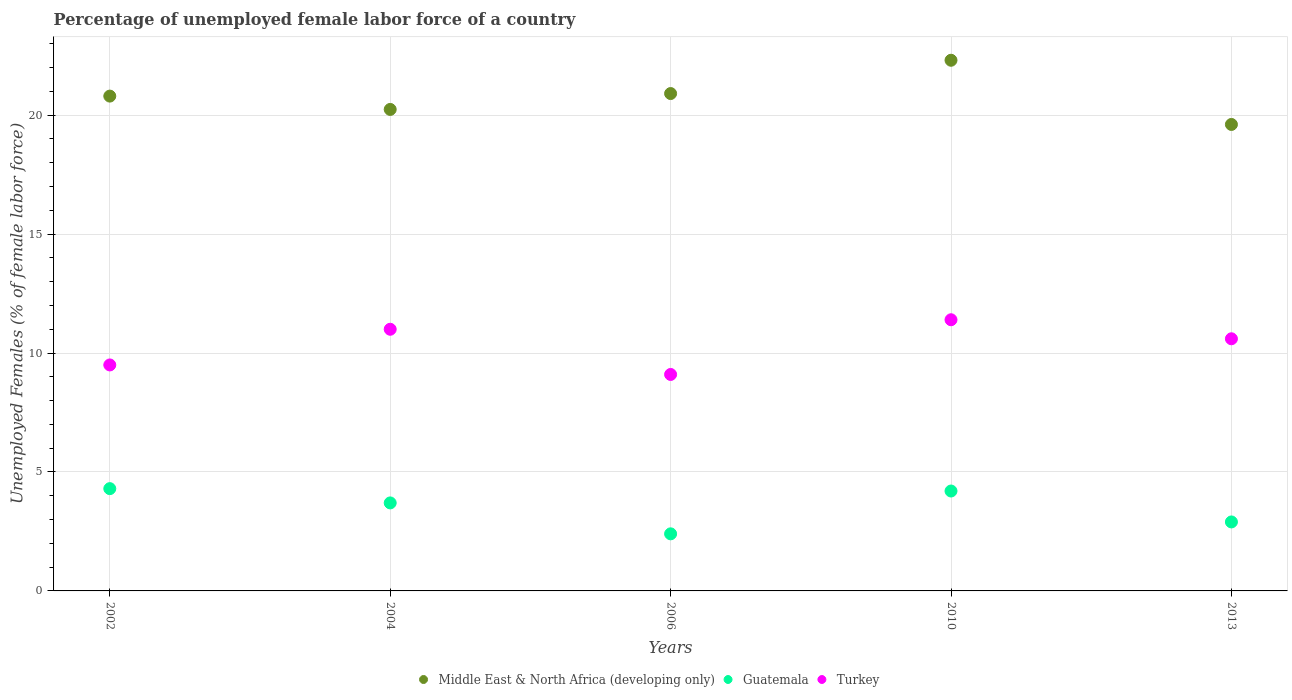How many different coloured dotlines are there?
Your answer should be very brief. 3. Is the number of dotlines equal to the number of legend labels?
Your answer should be compact. Yes. Across all years, what is the maximum percentage of unemployed female labor force in Middle East & North Africa (developing only)?
Give a very brief answer. 22.31. Across all years, what is the minimum percentage of unemployed female labor force in Guatemala?
Offer a very short reply. 2.4. In which year was the percentage of unemployed female labor force in Turkey minimum?
Your answer should be very brief. 2006. What is the total percentage of unemployed female labor force in Middle East & North Africa (developing only) in the graph?
Your answer should be very brief. 103.87. What is the difference between the percentage of unemployed female labor force in Middle East & North Africa (developing only) in 2010 and that in 2013?
Provide a succinct answer. 2.7. What is the difference between the percentage of unemployed female labor force in Middle East & North Africa (developing only) in 2006 and the percentage of unemployed female labor force in Guatemala in 2010?
Your answer should be compact. 16.71. What is the average percentage of unemployed female labor force in Middle East & North Africa (developing only) per year?
Offer a terse response. 20.77. In the year 2006, what is the difference between the percentage of unemployed female labor force in Middle East & North Africa (developing only) and percentage of unemployed female labor force in Turkey?
Your response must be concise. 11.81. What is the ratio of the percentage of unemployed female labor force in Guatemala in 2004 to that in 2010?
Give a very brief answer. 0.88. Is the percentage of unemployed female labor force in Turkey in 2006 less than that in 2010?
Provide a succinct answer. Yes. Is the difference between the percentage of unemployed female labor force in Middle East & North Africa (developing only) in 2002 and 2004 greater than the difference between the percentage of unemployed female labor force in Turkey in 2002 and 2004?
Your answer should be very brief. Yes. What is the difference between the highest and the second highest percentage of unemployed female labor force in Guatemala?
Keep it short and to the point. 0.1. What is the difference between the highest and the lowest percentage of unemployed female labor force in Turkey?
Make the answer very short. 2.3. In how many years, is the percentage of unemployed female labor force in Turkey greater than the average percentage of unemployed female labor force in Turkey taken over all years?
Keep it short and to the point. 3. Is it the case that in every year, the sum of the percentage of unemployed female labor force in Guatemala and percentage of unemployed female labor force in Turkey  is greater than the percentage of unemployed female labor force in Middle East & North Africa (developing only)?
Your answer should be very brief. No. Does the percentage of unemployed female labor force in Turkey monotonically increase over the years?
Your answer should be compact. No. Is the percentage of unemployed female labor force in Guatemala strictly less than the percentage of unemployed female labor force in Middle East & North Africa (developing only) over the years?
Provide a succinct answer. Yes. How many dotlines are there?
Provide a short and direct response. 3. What is the difference between two consecutive major ticks on the Y-axis?
Your response must be concise. 5. Where does the legend appear in the graph?
Make the answer very short. Bottom center. How many legend labels are there?
Give a very brief answer. 3. How are the legend labels stacked?
Ensure brevity in your answer.  Horizontal. What is the title of the graph?
Offer a terse response. Percentage of unemployed female labor force of a country. What is the label or title of the X-axis?
Provide a succinct answer. Years. What is the label or title of the Y-axis?
Ensure brevity in your answer.  Unemployed Females (% of female labor force). What is the Unemployed Females (% of female labor force) in Middle East & North Africa (developing only) in 2002?
Keep it short and to the point. 20.8. What is the Unemployed Females (% of female labor force) of Guatemala in 2002?
Your answer should be very brief. 4.3. What is the Unemployed Females (% of female labor force) of Middle East & North Africa (developing only) in 2004?
Ensure brevity in your answer.  20.24. What is the Unemployed Females (% of female labor force) of Guatemala in 2004?
Provide a succinct answer. 3.7. What is the Unemployed Females (% of female labor force) in Middle East & North Africa (developing only) in 2006?
Provide a succinct answer. 20.91. What is the Unemployed Females (% of female labor force) of Guatemala in 2006?
Your answer should be compact. 2.4. What is the Unemployed Females (% of female labor force) of Turkey in 2006?
Provide a short and direct response. 9.1. What is the Unemployed Females (% of female labor force) of Middle East & North Africa (developing only) in 2010?
Your answer should be compact. 22.31. What is the Unemployed Females (% of female labor force) of Guatemala in 2010?
Make the answer very short. 4.2. What is the Unemployed Females (% of female labor force) of Turkey in 2010?
Your answer should be compact. 11.4. What is the Unemployed Females (% of female labor force) in Middle East & North Africa (developing only) in 2013?
Keep it short and to the point. 19.61. What is the Unemployed Females (% of female labor force) in Guatemala in 2013?
Your answer should be compact. 2.9. What is the Unemployed Females (% of female labor force) of Turkey in 2013?
Keep it short and to the point. 10.6. Across all years, what is the maximum Unemployed Females (% of female labor force) of Middle East & North Africa (developing only)?
Provide a succinct answer. 22.31. Across all years, what is the maximum Unemployed Females (% of female labor force) of Guatemala?
Ensure brevity in your answer.  4.3. Across all years, what is the maximum Unemployed Females (% of female labor force) of Turkey?
Your answer should be very brief. 11.4. Across all years, what is the minimum Unemployed Females (% of female labor force) in Middle East & North Africa (developing only)?
Ensure brevity in your answer.  19.61. Across all years, what is the minimum Unemployed Females (% of female labor force) in Guatemala?
Provide a succinct answer. 2.4. Across all years, what is the minimum Unemployed Females (% of female labor force) in Turkey?
Your response must be concise. 9.1. What is the total Unemployed Females (% of female labor force) of Middle East & North Africa (developing only) in the graph?
Provide a succinct answer. 103.87. What is the total Unemployed Females (% of female labor force) of Guatemala in the graph?
Provide a succinct answer. 17.5. What is the total Unemployed Females (% of female labor force) of Turkey in the graph?
Offer a very short reply. 51.6. What is the difference between the Unemployed Females (% of female labor force) of Middle East & North Africa (developing only) in 2002 and that in 2004?
Ensure brevity in your answer.  0.56. What is the difference between the Unemployed Females (% of female labor force) in Guatemala in 2002 and that in 2004?
Provide a short and direct response. 0.6. What is the difference between the Unemployed Females (% of female labor force) in Turkey in 2002 and that in 2004?
Your answer should be compact. -1.5. What is the difference between the Unemployed Females (% of female labor force) of Middle East & North Africa (developing only) in 2002 and that in 2006?
Your response must be concise. -0.11. What is the difference between the Unemployed Females (% of female labor force) of Turkey in 2002 and that in 2006?
Your answer should be compact. 0.4. What is the difference between the Unemployed Females (% of female labor force) of Middle East & North Africa (developing only) in 2002 and that in 2010?
Your answer should be very brief. -1.51. What is the difference between the Unemployed Females (% of female labor force) of Turkey in 2002 and that in 2010?
Your answer should be compact. -1.9. What is the difference between the Unemployed Females (% of female labor force) of Middle East & North Africa (developing only) in 2002 and that in 2013?
Your answer should be very brief. 1.19. What is the difference between the Unemployed Females (% of female labor force) of Guatemala in 2002 and that in 2013?
Provide a short and direct response. 1.4. What is the difference between the Unemployed Females (% of female labor force) of Middle East & North Africa (developing only) in 2004 and that in 2006?
Your response must be concise. -0.67. What is the difference between the Unemployed Females (% of female labor force) of Turkey in 2004 and that in 2006?
Make the answer very short. 1.9. What is the difference between the Unemployed Females (% of female labor force) in Middle East & North Africa (developing only) in 2004 and that in 2010?
Your answer should be compact. -2.07. What is the difference between the Unemployed Females (% of female labor force) of Turkey in 2004 and that in 2010?
Your answer should be very brief. -0.4. What is the difference between the Unemployed Females (% of female labor force) of Middle East & North Africa (developing only) in 2004 and that in 2013?
Make the answer very short. 0.63. What is the difference between the Unemployed Females (% of female labor force) of Middle East & North Africa (developing only) in 2006 and that in 2010?
Give a very brief answer. -1.4. What is the difference between the Unemployed Females (% of female labor force) of Guatemala in 2006 and that in 2010?
Give a very brief answer. -1.8. What is the difference between the Unemployed Females (% of female labor force) of Turkey in 2006 and that in 2010?
Make the answer very short. -2.3. What is the difference between the Unemployed Females (% of female labor force) of Middle East & North Africa (developing only) in 2006 and that in 2013?
Offer a terse response. 1.3. What is the difference between the Unemployed Females (% of female labor force) in Guatemala in 2006 and that in 2013?
Make the answer very short. -0.5. What is the difference between the Unemployed Females (% of female labor force) of Middle East & North Africa (developing only) in 2010 and that in 2013?
Offer a terse response. 2.7. What is the difference between the Unemployed Females (% of female labor force) of Middle East & North Africa (developing only) in 2002 and the Unemployed Females (% of female labor force) of Guatemala in 2004?
Give a very brief answer. 17.1. What is the difference between the Unemployed Females (% of female labor force) of Middle East & North Africa (developing only) in 2002 and the Unemployed Females (% of female labor force) of Turkey in 2004?
Offer a terse response. 9.8. What is the difference between the Unemployed Females (% of female labor force) of Guatemala in 2002 and the Unemployed Females (% of female labor force) of Turkey in 2004?
Offer a terse response. -6.7. What is the difference between the Unemployed Females (% of female labor force) of Middle East & North Africa (developing only) in 2002 and the Unemployed Females (% of female labor force) of Guatemala in 2006?
Provide a short and direct response. 18.4. What is the difference between the Unemployed Females (% of female labor force) in Middle East & North Africa (developing only) in 2002 and the Unemployed Females (% of female labor force) in Turkey in 2006?
Offer a very short reply. 11.7. What is the difference between the Unemployed Females (% of female labor force) in Middle East & North Africa (developing only) in 2002 and the Unemployed Females (% of female labor force) in Guatemala in 2010?
Ensure brevity in your answer.  16.6. What is the difference between the Unemployed Females (% of female labor force) in Middle East & North Africa (developing only) in 2002 and the Unemployed Females (% of female labor force) in Turkey in 2010?
Give a very brief answer. 9.4. What is the difference between the Unemployed Females (% of female labor force) of Middle East & North Africa (developing only) in 2002 and the Unemployed Females (% of female labor force) of Guatemala in 2013?
Give a very brief answer. 17.9. What is the difference between the Unemployed Females (% of female labor force) in Middle East & North Africa (developing only) in 2002 and the Unemployed Females (% of female labor force) in Turkey in 2013?
Provide a short and direct response. 10.2. What is the difference between the Unemployed Females (% of female labor force) of Middle East & North Africa (developing only) in 2004 and the Unemployed Females (% of female labor force) of Guatemala in 2006?
Make the answer very short. 17.84. What is the difference between the Unemployed Females (% of female labor force) in Middle East & North Africa (developing only) in 2004 and the Unemployed Females (% of female labor force) in Turkey in 2006?
Provide a short and direct response. 11.14. What is the difference between the Unemployed Females (% of female labor force) in Guatemala in 2004 and the Unemployed Females (% of female labor force) in Turkey in 2006?
Make the answer very short. -5.4. What is the difference between the Unemployed Females (% of female labor force) of Middle East & North Africa (developing only) in 2004 and the Unemployed Females (% of female labor force) of Guatemala in 2010?
Make the answer very short. 16.04. What is the difference between the Unemployed Females (% of female labor force) in Middle East & North Africa (developing only) in 2004 and the Unemployed Females (% of female labor force) in Turkey in 2010?
Your answer should be compact. 8.84. What is the difference between the Unemployed Females (% of female labor force) of Middle East & North Africa (developing only) in 2004 and the Unemployed Females (% of female labor force) of Guatemala in 2013?
Make the answer very short. 17.34. What is the difference between the Unemployed Females (% of female labor force) of Middle East & North Africa (developing only) in 2004 and the Unemployed Females (% of female labor force) of Turkey in 2013?
Make the answer very short. 9.64. What is the difference between the Unemployed Females (% of female labor force) in Guatemala in 2004 and the Unemployed Females (% of female labor force) in Turkey in 2013?
Offer a terse response. -6.9. What is the difference between the Unemployed Females (% of female labor force) in Middle East & North Africa (developing only) in 2006 and the Unemployed Females (% of female labor force) in Guatemala in 2010?
Ensure brevity in your answer.  16.71. What is the difference between the Unemployed Females (% of female labor force) of Middle East & North Africa (developing only) in 2006 and the Unemployed Females (% of female labor force) of Turkey in 2010?
Your answer should be compact. 9.51. What is the difference between the Unemployed Females (% of female labor force) in Guatemala in 2006 and the Unemployed Females (% of female labor force) in Turkey in 2010?
Your response must be concise. -9. What is the difference between the Unemployed Females (% of female labor force) of Middle East & North Africa (developing only) in 2006 and the Unemployed Females (% of female labor force) of Guatemala in 2013?
Your answer should be compact. 18.01. What is the difference between the Unemployed Females (% of female labor force) of Middle East & North Africa (developing only) in 2006 and the Unemployed Females (% of female labor force) of Turkey in 2013?
Provide a succinct answer. 10.31. What is the difference between the Unemployed Females (% of female labor force) of Guatemala in 2006 and the Unemployed Females (% of female labor force) of Turkey in 2013?
Ensure brevity in your answer.  -8.2. What is the difference between the Unemployed Females (% of female labor force) of Middle East & North Africa (developing only) in 2010 and the Unemployed Females (% of female labor force) of Guatemala in 2013?
Offer a terse response. 19.41. What is the difference between the Unemployed Females (% of female labor force) of Middle East & North Africa (developing only) in 2010 and the Unemployed Females (% of female labor force) of Turkey in 2013?
Keep it short and to the point. 11.71. What is the difference between the Unemployed Females (% of female labor force) in Guatemala in 2010 and the Unemployed Females (% of female labor force) in Turkey in 2013?
Provide a succinct answer. -6.4. What is the average Unemployed Females (% of female labor force) in Middle East & North Africa (developing only) per year?
Provide a succinct answer. 20.77. What is the average Unemployed Females (% of female labor force) of Guatemala per year?
Provide a succinct answer. 3.5. What is the average Unemployed Females (% of female labor force) of Turkey per year?
Provide a short and direct response. 10.32. In the year 2002, what is the difference between the Unemployed Females (% of female labor force) in Middle East & North Africa (developing only) and Unemployed Females (% of female labor force) in Guatemala?
Offer a terse response. 16.5. In the year 2002, what is the difference between the Unemployed Females (% of female labor force) in Middle East & North Africa (developing only) and Unemployed Females (% of female labor force) in Turkey?
Make the answer very short. 11.3. In the year 2004, what is the difference between the Unemployed Females (% of female labor force) of Middle East & North Africa (developing only) and Unemployed Females (% of female labor force) of Guatemala?
Offer a very short reply. 16.54. In the year 2004, what is the difference between the Unemployed Females (% of female labor force) of Middle East & North Africa (developing only) and Unemployed Females (% of female labor force) of Turkey?
Offer a terse response. 9.24. In the year 2006, what is the difference between the Unemployed Females (% of female labor force) in Middle East & North Africa (developing only) and Unemployed Females (% of female labor force) in Guatemala?
Your answer should be very brief. 18.51. In the year 2006, what is the difference between the Unemployed Females (% of female labor force) in Middle East & North Africa (developing only) and Unemployed Females (% of female labor force) in Turkey?
Give a very brief answer. 11.81. In the year 2010, what is the difference between the Unemployed Females (% of female labor force) in Middle East & North Africa (developing only) and Unemployed Females (% of female labor force) in Guatemala?
Make the answer very short. 18.11. In the year 2010, what is the difference between the Unemployed Females (% of female labor force) in Middle East & North Africa (developing only) and Unemployed Females (% of female labor force) in Turkey?
Keep it short and to the point. 10.91. In the year 2010, what is the difference between the Unemployed Females (% of female labor force) of Guatemala and Unemployed Females (% of female labor force) of Turkey?
Make the answer very short. -7.2. In the year 2013, what is the difference between the Unemployed Females (% of female labor force) of Middle East & North Africa (developing only) and Unemployed Females (% of female labor force) of Guatemala?
Your answer should be very brief. 16.71. In the year 2013, what is the difference between the Unemployed Females (% of female labor force) in Middle East & North Africa (developing only) and Unemployed Females (% of female labor force) in Turkey?
Keep it short and to the point. 9.01. In the year 2013, what is the difference between the Unemployed Females (% of female labor force) in Guatemala and Unemployed Females (% of female labor force) in Turkey?
Provide a short and direct response. -7.7. What is the ratio of the Unemployed Females (% of female labor force) of Middle East & North Africa (developing only) in 2002 to that in 2004?
Your answer should be compact. 1.03. What is the ratio of the Unemployed Females (% of female labor force) of Guatemala in 2002 to that in 2004?
Make the answer very short. 1.16. What is the ratio of the Unemployed Females (% of female labor force) of Turkey in 2002 to that in 2004?
Provide a succinct answer. 0.86. What is the ratio of the Unemployed Females (% of female labor force) of Guatemala in 2002 to that in 2006?
Offer a very short reply. 1.79. What is the ratio of the Unemployed Females (% of female labor force) in Turkey in 2002 to that in 2006?
Make the answer very short. 1.04. What is the ratio of the Unemployed Females (% of female labor force) in Middle East & North Africa (developing only) in 2002 to that in 2010?
Keep it short and to the point. 0.93. What is the ratio of the Unemployed Females (% of female labor force) in Guatemala in 2002 to that in 2010?
Your answer should be compact. 1.02. What is the ratio of the Unemployed Females (% of female labor force) of Turkey in 2002 to that in 2010?
Your answer should be very brief. 0.83. What is the ratio of the Unemployed Females (% of female labor force) of Middle East & North Africa (developing only) in 2002 to that in 2013?
Ensure brevity in your answer.  1.06. What is the ratio of the Unemployed Females (% of female labor force) of Guatemala in 2002 to that in 2013?
Ensure brevity in your answer.  1.48. What is the ratio of the Unemployed Females (% of female labor force) of Turkey in 2002 to that in 2013?
Give a very brief answer. 0.9. What is the ratio of the Unemployed Females (% of female labor force) in Middle East & North Africa (developing only) in 2004 to that in 2006?
Your answer should be compact. 0.97. What is the ratio of the Unemployed Females (% of female labor force) of Guatemala in 2004 to that in 2006?
Offer a terse response. 1.54. What is the ratio of the Unemployed Females (% of female labor force) of Turkey in 2004 to that in 2006?
Your response must be concise. 1.21. What is the ratio of the Unemployed Females (% of female labor force) of Middle East & North Africa (developing only) in 2004 to that in 2010?
Offer a very short reply. 0.91. What is the ratio of the Unemployed Females (% of female labor force) of Guatemala in 2004 to that in 2010?
Make the answer very short. 0.88. What is the ratio of the Unemployed Females (% of female labor force) of Turkey in 2004 to that in 2010?
Offer a very short reply. 0.96. What is the ratio of the Unemployed Females (% of female labor force) in Middle East & North Africa (developing only) in 2004 to that in 2013?
Offer a terse response. 1.03. What is the ratio of the Unemployed Females (% of female labor force) of Guatemala in 2004 to that in 2013?
Give a very brief answer. 1.28. What is the ratio of the Unemployed Females (% of female labor force) in Turkey in 2004 to that in 2013?
Your response must be concise. 1.04. What is the ratio of the Unemployed Females (% of female labor force) in Middle East & North Africa (developing only) in 2006 to that in 2010?
Provide a short and direct response. 0.94. What is the ratio of the Unemployed Females (% of female labor force) in Guatemala in 2006 to that in 2010?
Your answer should be compact. 0.57. What is the ratio of the Unemployed Females (% of female labor force) in Turkey in 2006 to that in 2010?
Your answer should be compact. 0.8. What is the ratio of the Unemployed Females (% of female labor force) in Middle East & North Africa (developing only) in 2006 to that in 2013?
Give a very brief answer. 1.07. What is the ratio of the Unemployed Females (% of female labor force) of Guatemala in 2006 to that in 2013?
Ensure brevity in your answer.  0.83. What is the ratio of the Unemployed Females (% of female labor force) in Turkey in 2006 to that in 2013?
Your response must be concise. 0.86. What is the ratio of the Unemployed Females (% of female labor force) in Middle East & North Africa (developing only) in 2010 to that in 2013?
Keep it short and to the point. 1.14. What is the ratio of the Unemployed Females (% of female labor force) of Guatemala in 2010 to that in 2013?
Provide a succinct answer. 1.45. What is the ratio of the Unemployed Females (% of female labor force) in Turkey in 2010 to that in 2013?
Make the answer very short. 1.08. What is the difference between the highest and the second highest Unemployed Females (% of female labor force) of Middle East & North Africa (developing only)?
Keep it short and to the point. 1.4. What is the difference between the highest and the lowest Unemployed Females (% of female labor force) in Middle East & North Africa (developing only)?
Provide a succinct answer. 2.7. 